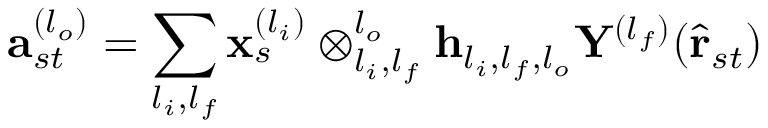<formula> <loc_0><loc_0><loc_500><loc_500>a _ { s t } ^ { ( l _ { o } ) } = \sum _ { l _ { i } , l _ { f } } x _ { s } ^ { ( l _ { i } ) } \otimes _ { l _ { i } , l _ { f } } ^ { l _ { o } } h _ { l _ { i } , l _ { f } , l _ { o } } Y ^ { ( l _ { f } ) } ( \hat { r } _ { s t } )</formula> 